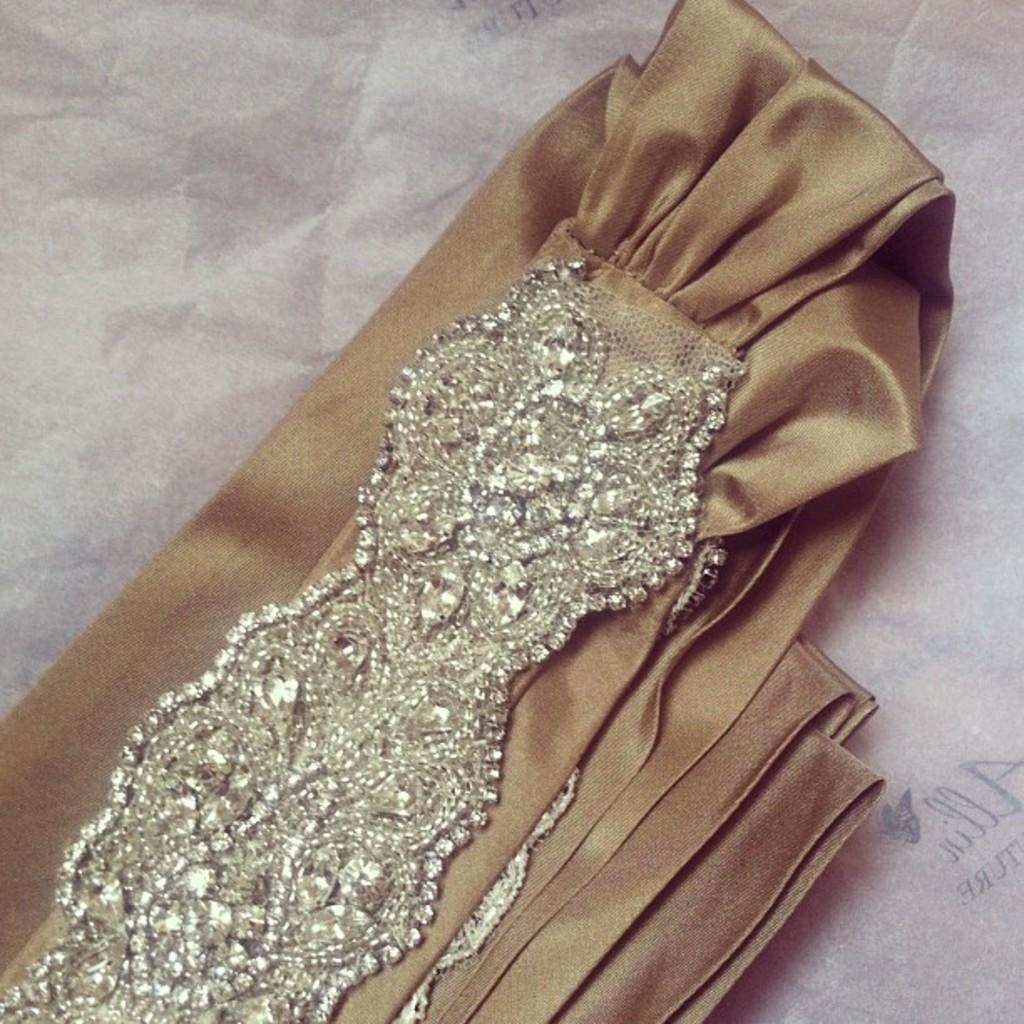What is the main object in the image? There is a cloth present in the image. Where is the cloth located in the image? The cloth is in the middle of the image. What else can be seen in the background of the image? There is an object that resembles a paper in the background of the image. What type of sea creatures can be seen swimming around the cloth in the image? There are no sea creatures present in the image; it features a cloth in the middle of the frame with a paper-like object in the background. 